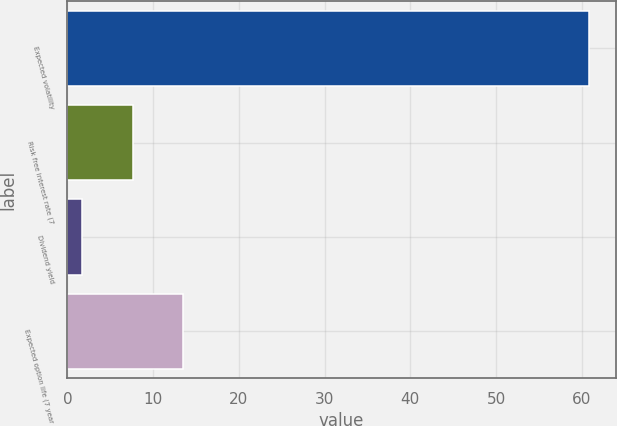Convert chart. <chart><loc_0><loc_0><loc_500><loc_500><bar_chart><fcel>Expected volatility<fcel>Risk free interest rate (7<fcel>Dividend yield<fcel>Expected option life (7 year<nl><fcel>60.9<fcel>7.6<fcel>1.68<fcel>13.52<nl></chart> 